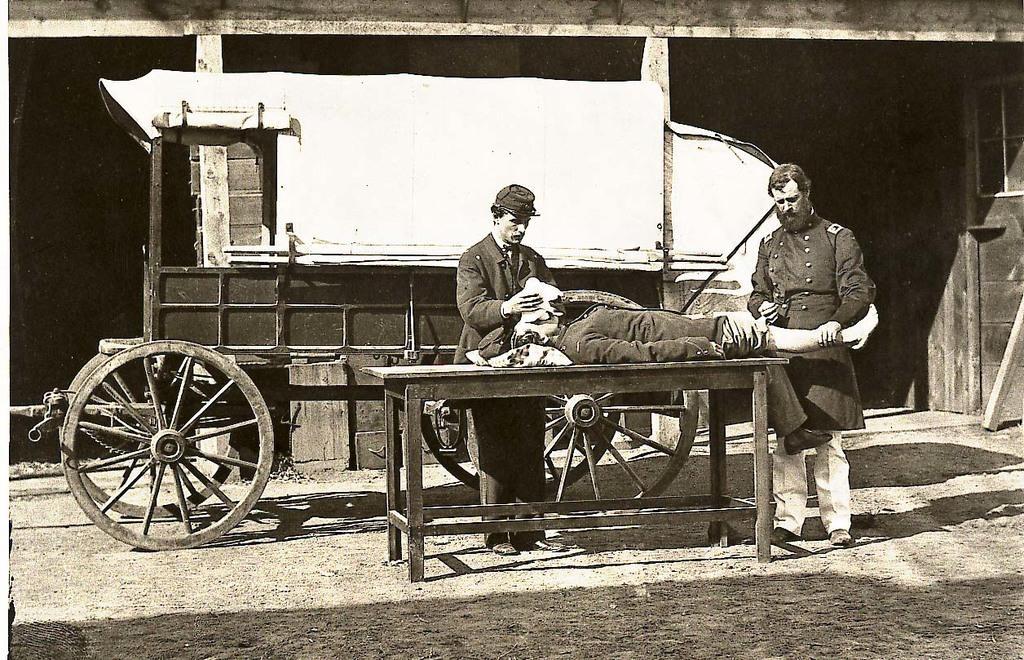Please provide a concise description of this image. In the image we can see two people standing and one is lying, they are wearing clothes and the left side person is wearing a cap. Here we can see a table, cart and wheels. 